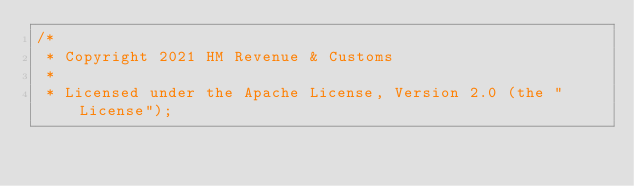Convert code to text. <code><loc_0><loc_0><loc_500><loc_500><_Scala_>/*
 * Copyright 2021 HM Revenue & Customs
 *
 * Licensed under the Apache License, Version 2.0 (the "License");</code> 